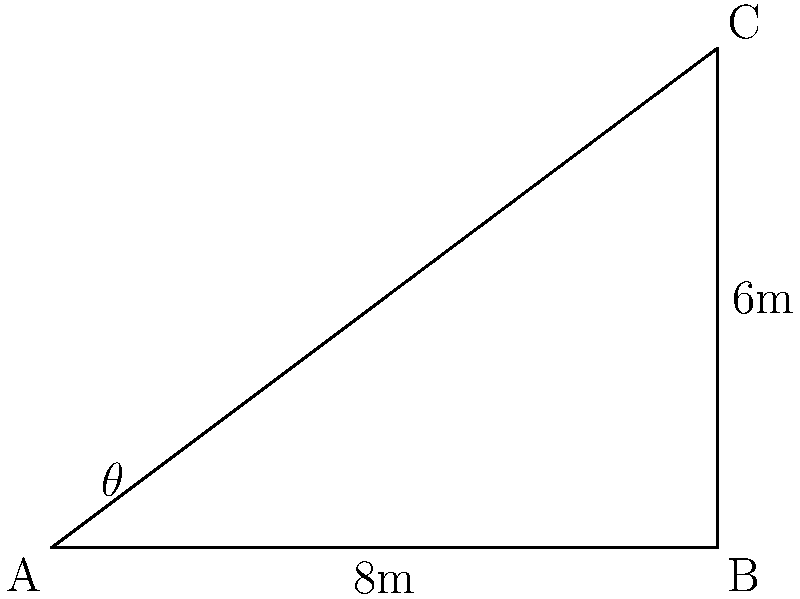Na casa da árvore da Turma do Balão Mágico, Simony e Mike querem conectar duas plataformas. A plataforma de Simony (ponto A) está a 8 metros de distância horizontal da base da árvore onde está a plataforma de Mike (ponto B). A plataforma de Mike está 6 metros acima da de Simony. Qual é a distância direta entre as duas plataformas? Vamos resolver isso passo a passo, como se estivéssemos planejando uma brincadeira divertida:

1) Primeiro, vemos que temos um triângulo retângulo ABC, onde:
   - AB é a distância horizontal entre as plataformas (8 metros)
   - BC é a altura entre as plataformas (6 metros)
   - AC é a distância direta que queremos encontrar

2) Para encontrar AC, podemos usar o Teorema de Pitágoras:

   $AC^2 = AB^2 + BC^2$

3) Substituindo os valores:

   $AC^2 = 8^2 + 6^2$

4) Calculando:

   $AC^2 = 64 + 36 = 100$

5) Para encontrar AC, tiramos a raiz quadrada dos dois lados:

   $AC = \sqrt{100} = 10$

Então, a distância direta entre as duas plataformas é de 10 metros!
Answer: 10 metros 